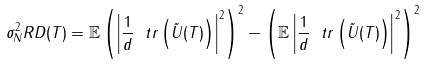Convert formula to latex. <formula><loc_0><loc_0><loc_500><loc_500>\sigma ^ { 2 } _ { N } R D ( T ) = \mathbb { E } \left ( \left | \frac { 1 } { d } \ t r \left ( \tilde { U } ( T ) \right ) \right | ^ { 2 } \right ) ^ { 2 } - \left ( \mathbb { E } \left | \frac { 1 } { d } \ t r \left ( \tilde { U } ( T ) \right ) \right | ^ { 2 } \right ) ^ { 2 }</formula> 